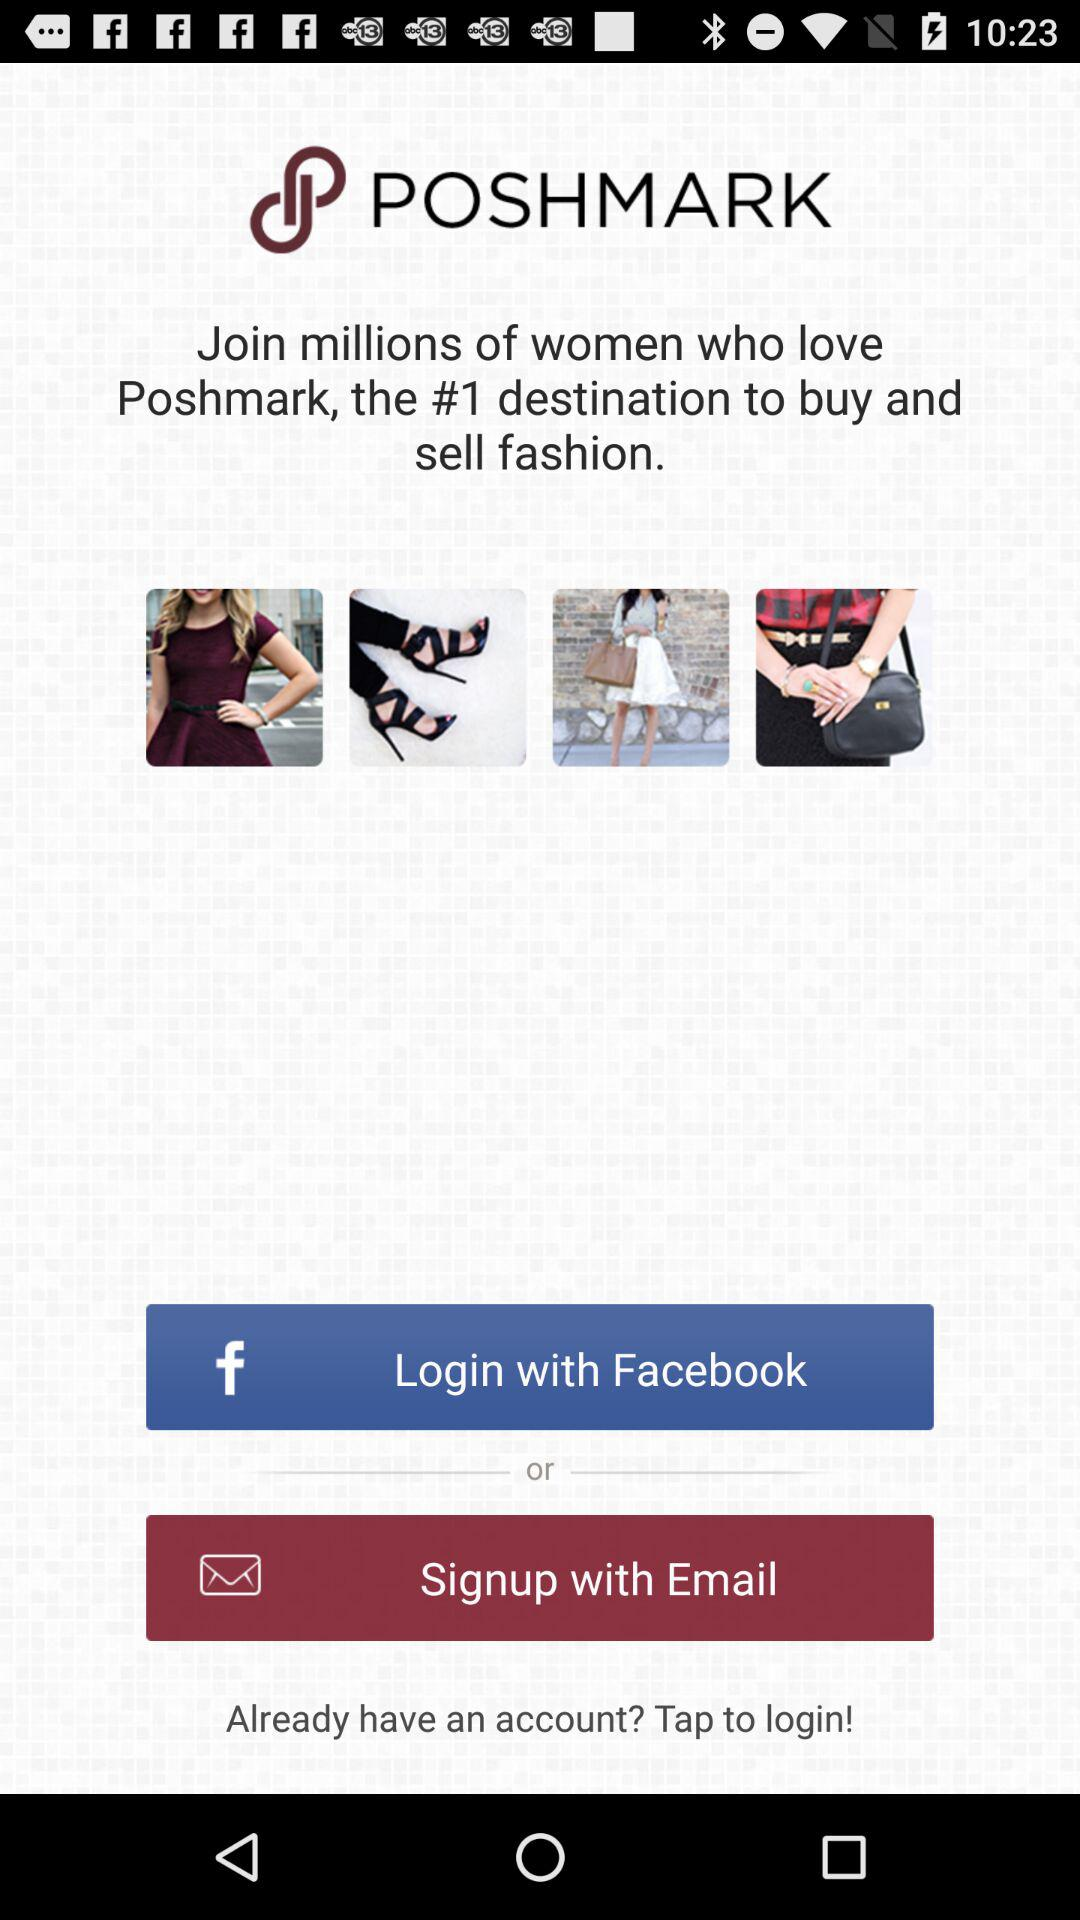What is the name of the application? The name of the application is "POSHMARK". 